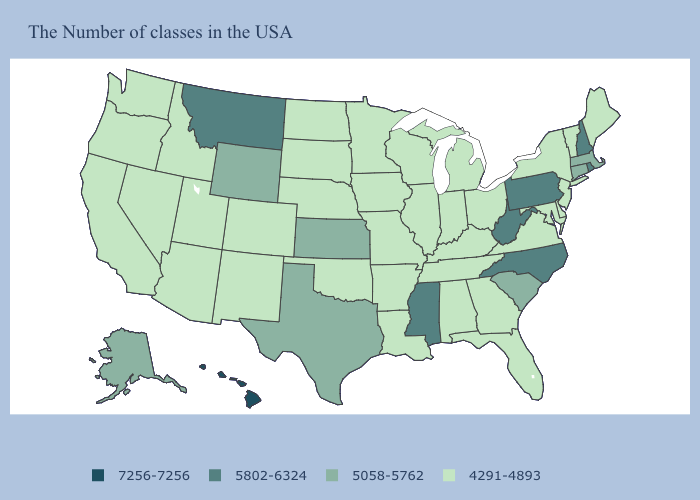What is the value of Utah?
Quick response, please. 4291-4893. Does West Virginia have a lower value than Illinois?
Answer briefly. No. Which states have the lowest value in the USA?
Keep it brief. Maine, Vermont, New York, New Jersey, Delaware, Maryland, Virginia, Ohio, Florida, Georgia, Michigan, Kentucky, Indiana, Alabama, Tennessee, Wisconsin, Illinois, Louisiana, Missouri, Arkansas, Minnesota, Iowa, Nebraska, Oklahoma, South Dakota, North Dakota, Colorado, New Mexico, Utah, Arizona, Idaho, Nevada, California, Washington, Oregon. What is the highest value in states that border Vermont?
Keep it brief. 5802-6324. What is the lowest value in states that border New Hampshire?
Short answer required. 4291-4893. Name the states that have a value in the range 7256-7256?
Write a very short answer. Hawaii. What is the highest value in the USA?
Keep it brief. 7256-7256. What is the lowest value in states that border Oklahoma?
Be succinct. 4291-4893. Does Ohio have a lower value than North Dakota?
Be succinct. No. Does the first symbol in the legend represent the smallest category?
Concise answer only. No. What is the highest value in states that border Oregon?
Write a very short answer. 4291-4893. Which states have the lowest value in the USA?
Concise answer only. Maine, Vermont, New York, New Jersey, Delaware, Maryland, Virginia, Ohio, Florida, Georgia, Michigan, Kentucky, Indiana, Alabama, Tennessee, Wisconsin, Illinois, Louisiana, Missouri, Arkansas, Minnesota, Iowa, Nebraska, Oklahoma, South Dakota, North Dakota, Colorado, New Mexico, Utah, Arizona, Idaho, Nevada, California, Washington, Oregon. Which states hav the highest value in the Northeast?
Be succinct. Rhode Island, New Hampshire, Pennsylvania. Does Iowa have the same value as Virginia?
Give a very brief answer. Yes. Does Texas have the lowest value in the USA?
Short answer required. No. 